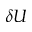<formula> <loc_0><loc_0><loc_500><loc_500>\delta U</formula> 